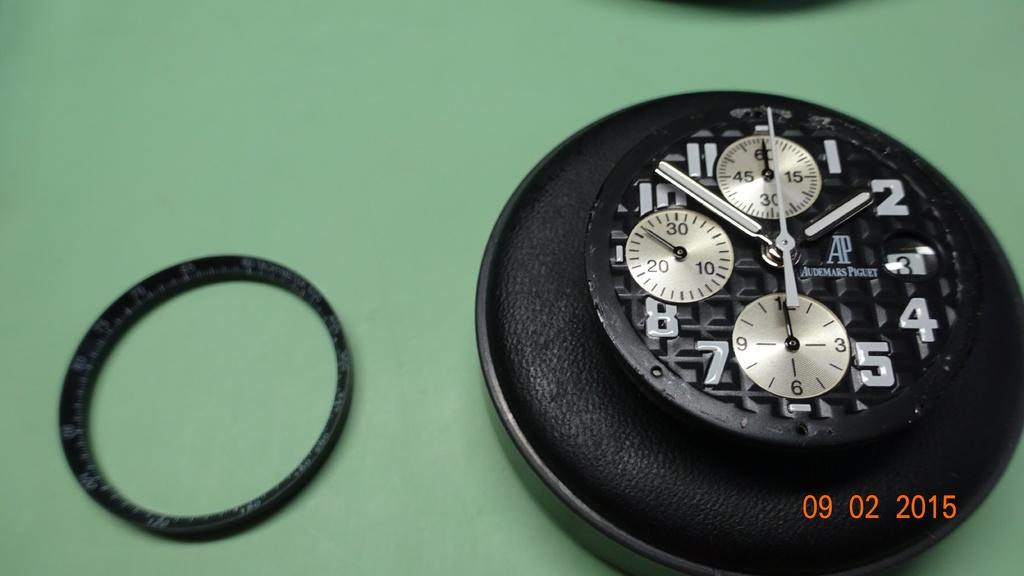What time is it?
Provide a succinct answer. 1:52. What date is on the photo?
Your answer should be compact. 09 02 2015. 